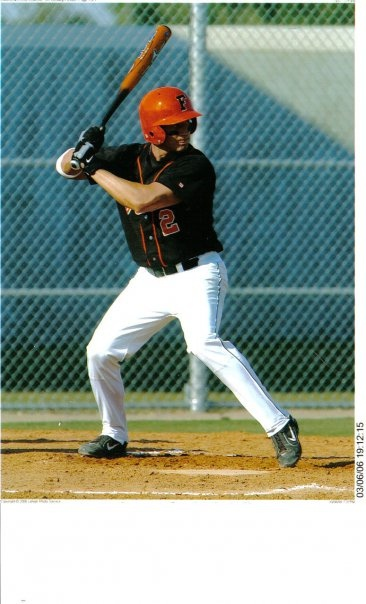Describe the objects in this image and their specific colors. I can see people in white, black, teal, and darkgray tones and baseball bat in white, black, brown, maroon, and gray tones in this image. 